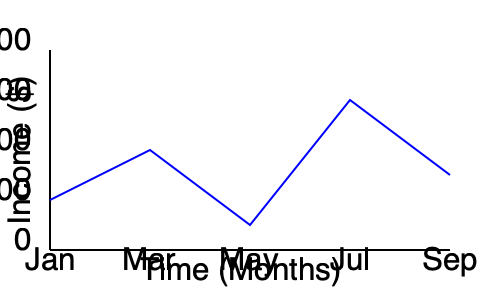As a freelancer managing multiple clients, you've tracked your income over the past 9 months. Based on the line graph, calculate the total change in income from January to September, and determine the month with the highest income fluctuation compared to the previous month. To solve this problem, we'll follow these steps:

1. Identify the income values for January and September:
   January (start): $2,500
   September (end): $3,750

2. Calculate the total change in income:
   $\text{Total change} = \text{September income} - \text{January income}$
   $\text{Total change} = $3,750 - $2,500 = $1,250$

3. To find the month with the highest income fluctuation, we'll calculate the change between each consecutive month:

   Jan to Mar: $3,500 - $2,500 = $1,000$ increase
   Mar to May: $1,250 - $3,500 = -$2,250$ decrease
   May to Jul: $6,000 - $1,250 = $4,750$ increase
   Jul to Sep: $3,750 - $6,000 = -$2,250$ decrease

4. Compare the absolute values of these fluctuations:
   |Jan to Mar| = $1,000
   |Mar to May| = $2,250
   |May to Jul| = $4,750
   |Jul to Sep| = $2,250

The highest fluctuation is $4,750, which occurred between May and July.
Answer: $1,250 increase; May to July 